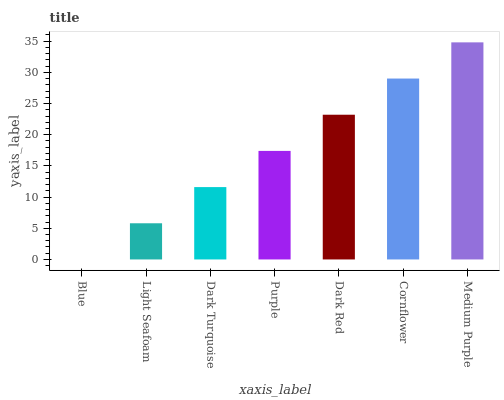Is Blue the minimum?
Answer yes or no. Yes. Is Medium Purple the maximum?
Answer yes or no. Yes. Is Light Seafoam the minimum?
Answer yes or no. No. Is Light Seafoam the maximum?
Answer yes or no. No. Is Light Seafoam greater than Blue?
Answer yes or no. Yes. Is Blue less than Light Seafoam?
Answer yes or no. Yes. Is Blue greater than Light Seafoam?
Answer yes or no. No. Is Light Seafoam less than Blue?
Answer yes or no. No. Is Purple the high median?
Answer yes or no. Yes. Is Purple the low median?
Answer yes or no. Yes. Is Dark Red the high median?
Answer yes or no. No. Is Dark Red the low median?
Answer yes or no. No. 